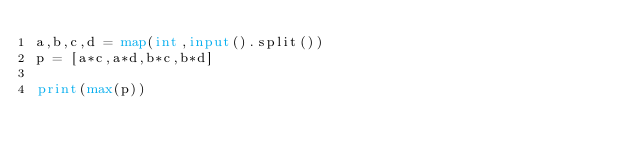Convert code to text. <code><loc_0><loc_0><loc_500><loc_500><_Python_>a,b,c,d = map(int,input().split())
p = [a*c,a*d,b*c,b*d]

print(max(p))</code> 